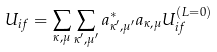<formula> <loc_0><loc_0><loc_500><loc_500>U _ { i f } = \sum _ { \kappa , \mu } \sum _ { \kappa ^ { \prime } , \mu ^ { \prime } } a ^ { * } _ { \kappa ^ { \prime } , \mu ^ { \prime } } a _ { \kappa , \mu } U ^ { ( L = 0 ) } _ { i f }</formula> 